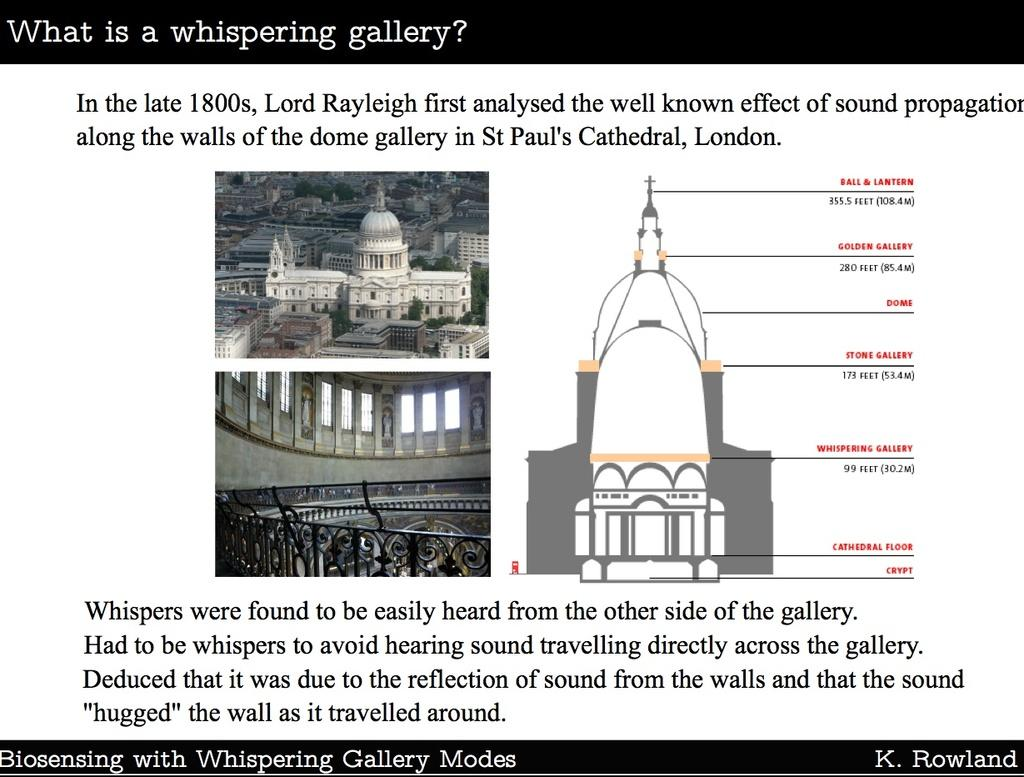<image>
Describe the image concisely. An overview of what a whispering gallery is by K. Rowland. 